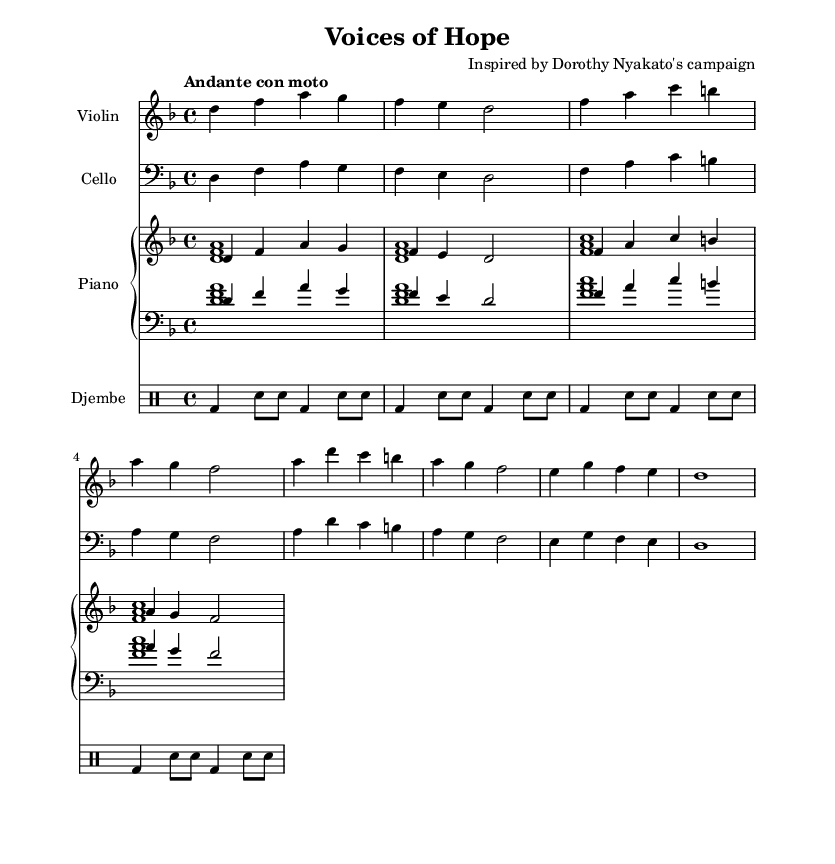What is the key signature of this music? The key signature is found at the beginning of the staff where it shows the note D with one flat. This indicates the key of D minor, which has one flat note (B flat).
Answer: D minor What is the time signature of this music? The time signature is indicated at the beginning of the piece, showing a '4' over a '4'. This means there are four beats in each measure, and the quarter note receives one beat.
Answer: Four over four What is the tempo marking for this piece? The tempo marking is noted at the beginning of the score, which is "Andante con moto." This term means to play at a moderate walking pace with motion, indicating a slightly faster feel.
Answer: Andante con moto How many measures are in the violin part? By counting the complete groups of notes separated by vertical bar lines, we can determine there are eight measures in the violin part.
Answer: Eight Which instruments are featured in this score? The instruments are listed at the beginning of each staff and include violin, cello, piano, and djembe. This shows the diverse instrumentation used in the piece.
Answer: Violin, cello, piano, djembe What type of composition is "Voices of Hope"? The title and the context provided indicate that this is a soundtrack, specifically composed to evoke emotions related to women's rights struggles in developing nations.
Answer: Soundtrack What is the rhythmic pattern used in the drum part? The rhythmic pattern can be analyzed by looking at the note types and grouping. The drum part alternates between bass drum hits and snare hits, creating a consistent and driving rhythm throughout.
Answer: Alternating bass and snare 